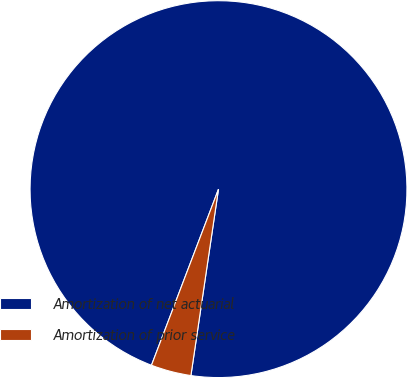Convert chart to OTSL. <chart><loc_0><loc_0><loc_500><loc_500><pie_chart><fcel>Amortization of net actuarial<fcel>Amortization of prior service<nl><fcel>96.55%<fcel>3.45%<nl></chart> 